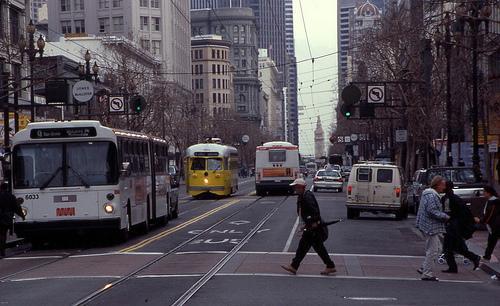How many pedestrians are in the photo?
Give a very brief answer. 5. How many vehicles are visible in foreground of the photo?
Give a very brief answer. 6. 